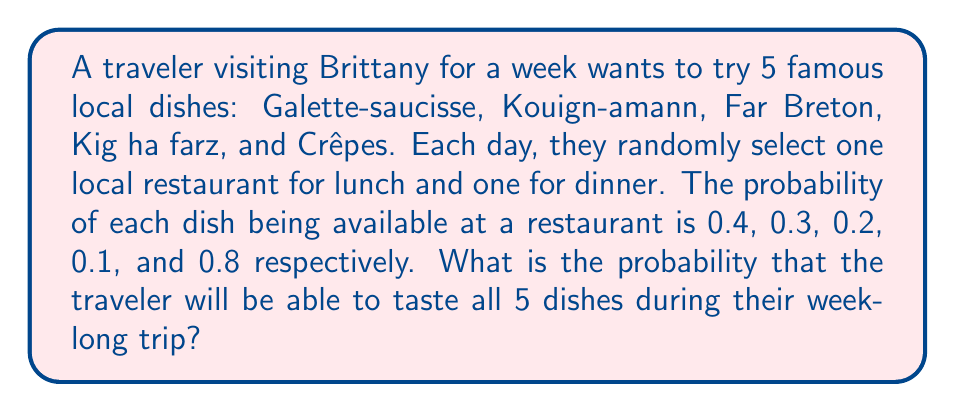Solve this math problem. Let's approach this step-by-step:

1) First, let's calculate the probability of not tasting each dish in a single meal:

   Galette-saucisse: $1 - 0.4 = 0.6$
   Kouign-amann: $1 - 0.3 = 0.7$
   Far Breton: $1 - 0.2 = 0.8$
   Kig ha farz: $1 - 0.1 = 0.9$
   Crêpes: $1 - 0.8 = 0.2$

2) In a week-long trip, there are 14 meals (7 lunches and 7 dinners). The probability of not tasting a specific dish in all 14 meals is:

   Galette-saucisse: $0.6^{14}$
   Kouign-amann: $0.7^{14}$
   Far Breton: $0.8^{14}$
   Kig ha farz: $0.9^{14}$
   Crêpes: $0.2^{14}$

3) The probability of tasting each dish at least once is the complement of not tasting it at all:

   Galette-saucisse: $1 - 0.6^{14}$
   Kouign-amann: $1 - 0.7^{14}$
   Far Breton: $1 - 0.8^{14}$
   Kig ha farz: $1 - 0.9^{14}$
   Crêpes: $1 - 0.2^{14}$

4) The probability of tasting all 5 dishes is the product of these individual probabilities:

   $$P(\text{all 5}) = (1 - 0.6^{14})(1 - 0.7^{14})(1 - 0.8^{14})(1 - 0.9^{14})(1 - 0.2^{14})$$

5) Calculating this:

   $$P(\text{all 5}) \approx 0.9999 \times 0.9994 \times 0.9942 \times 0.7693 \times 1.0000 \approx 0.7639$$
Answer: $0.7639$ or $76.39\%$ 